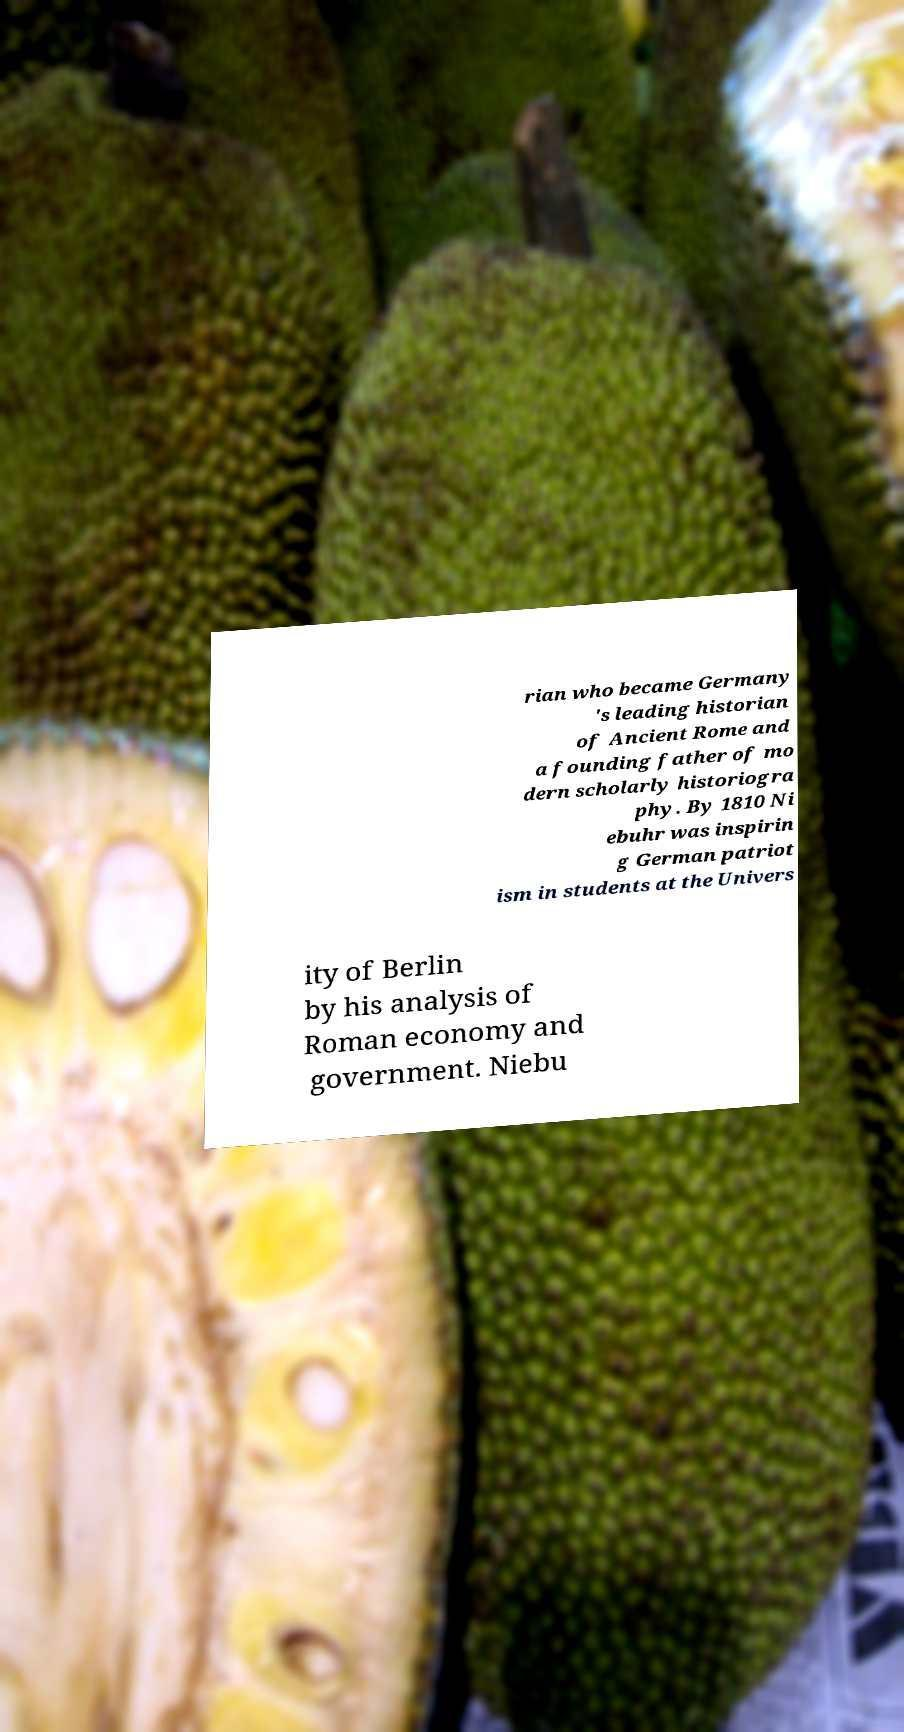Can you read and provide the text displayed in the image?This photo seems to have some interesting text. Can you extract and type it out for me? rian who became Germany 's leading historian of Ancient Rome and a founding father of mo dern scholarly historiogra phy. By 1810 Ni ebuhr was inspirin g German patriot ism in students at the Univers ity of Berlin by his analysis of Roman economy and government. Niebu 